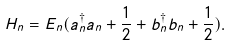<formula> <loc_0><loc_0><loc_500><loc_500>H _ { n } = E _ { n } ( a _ { n } ^ { \dagger } a _ { n } + \frac { 1 } { 2 } + b _ { n } ^ { \dagger } b _ { n } + \frac { 1 } { 2 } ) .</formula> 